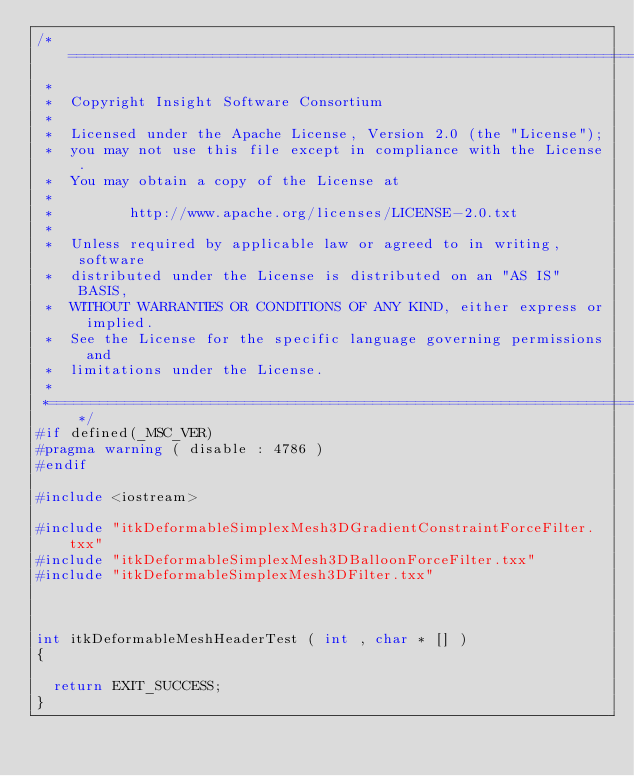Convert code to text. <code><loc_0><loc_0><loc_500><loc_500><_C++_>/*=========================================================================
 *
 *  Copyright Insight Software Consortium
 *
 *  Licensed under the Apache License, Version 2.0 (the "License");
 *  you may not use this file except in compliance with the License.
 *  You may obtain a copy of the License at
 *
 *         http://www.apache.org/licenses/LICENSE-2.0.txt
 *
 *  Unless required by applicable law or agreed to in writing, software
 *  distributed under the License is distributed on an "AS IS" BASIS,
 *  WITHOUT WARRANTIES OR CONDITIONS OF ANY KIND, either express or implied.
 *  See the License for the specific language governing permissions and
 *  limitations under the License.
 *
 *=========================================================================*/
#if defined(_MSC_VER)
#pragma warning ( disable : 4786 )
#endif

#include <iostream>

#include "itkDeformableSimplexMesh3DGradientConstraintForceFilter.txx"
#include "itkDeformableSimplexMesh3DBalloonForceFilter.txx"
#include "itkDeformableSimplexMesh3DFilter.txx"



int itkDeformableMeshHeaderTest ( int , char * [] )
{

  return EXIT_SUCCESS;
}
</code> 